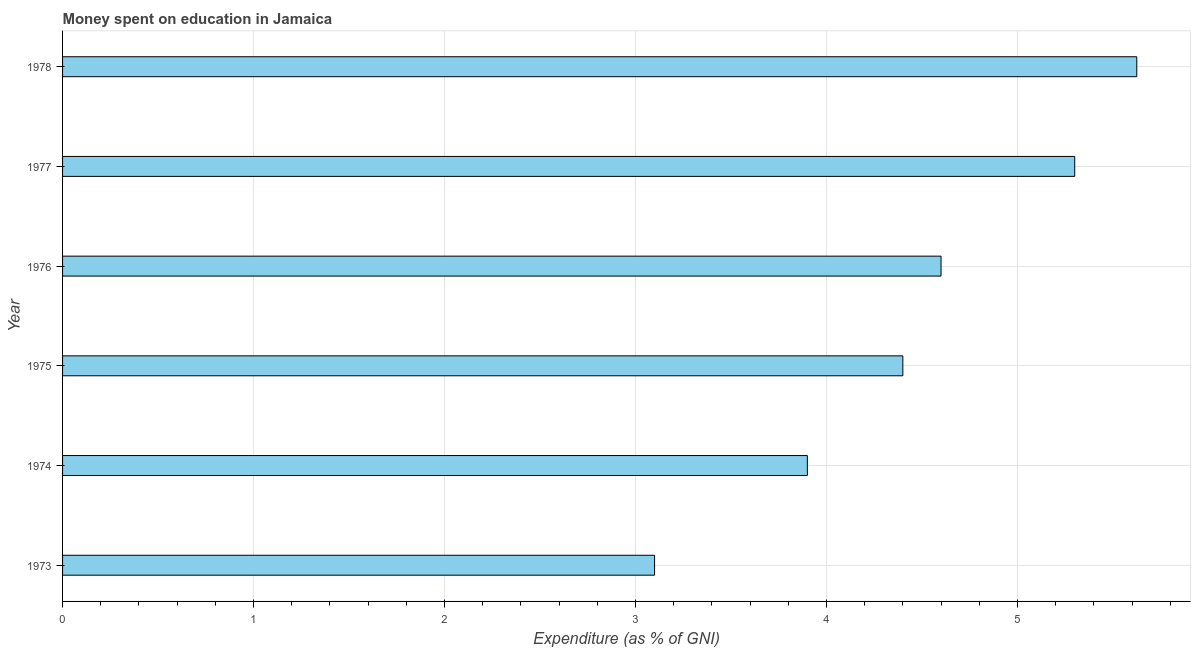Does the graph contain any zero values?
Offer a terse response. No. Does the graph contain grids?
Offer a terse response. Yes. What is the title of the graph?
Your answer should be compact. Money spent on education in Jamaica. What is the label or title of the X-axis?
Your answer should be very brief. Expenditure (as % of GNI). What is the label or title of the Y-axis?
Give a very brief answer. Year. What is the expenditure on education in 1978?
Your response must be concise. 5.63. Across all years, what is the maximum expenditure on education?
Ensure brevity in your answer.  5.63. Across all years, what is the minimum expenditure on education?
Provide a short and direct response. 3.1. In which year was the expenditure on education maximum?
Provide a succinct answer. 1978. What is the sum of the expenditure on education?
Your response must be concise. 26.93. What is the difference between the expenditure on education in 1975 and 1977?
Your response must be concise. -0.9. What is the average expenditure on education per year?
Ensure brevity in your answer.  4.49. In how many years, is the expenditure on education greater than 2.4 %?
Give a very brief answer. 6. What is the ratio of the expenditure on education in 1975 to that in 1976?
Give a very brief answer. 0.96. Is the expenditure on education in 1975 less than that in 1977?
Give a very brief answer. Yes. What is the difference between the highest and the second highest expenditure on education?
Ensure brevity in your answer.  0.33. What is the difference between the highest and the lowest expenditure on education?
Your response must be concise. 2.53. How many bars are there?
Keep it short and to the point. 6. How many years are there in the graph?
Offer a terse response. 6. What is the difference between two consecutive major ticks on the X-axis?
Your response must be concise. 1. What is the Expenditure (as % of GNI) of 1973?
Your answer should be compact. 3.1. What is the Expenditure (as % of GNI) in 1974?
Give a very brief answer. 3.9. What is the Expenditure (as % of GNI) in 1976?
Offer a terse response. 4.6. What is the Expenditure (as % of GNI) of 1978?
Provide a short and direct response. 5.63. What is the difference between the Expenditure (as % of GNI) in 1973 and 1975?
Your response must be concise. -1.3. What is the difference between the Expenditure (as % of GNI) in 1973 and 1977?
Provide a short and direct response. -2.2. What is the difference between the Expenditure (as % of GNI) in 1973 and 1978?
Offer a very short reply. -2.52. What is the difference between the Expenditure (as % of GNI) in 1974 and 1976?
Provide a short and direct response. -0.7. What is the difference between the Expenditure (as % of GNI) in 1974 and 1978?
Provide a succinct answer. -1.73. What is the difference between the Expenditure (as % of GNI) in 1975 and 1976?
Your answer should be very brief. -0.2. What is the difference between the Expenditure (as % of GNI) in 1975 and 1978?
Provide a short and direct response. -1.23. What is the difference between the Expenditure (as % of GNI) in 1976 and 1977?
Your response must be concise. -0.7. What is the difference between the Expenditure (as % of GNI) in 1976 and 1978?
Make the answer very short. -1.02. What is the difference between the Expenditure (as % of GNI) in 1977 and 1978?
Make the answer very short. -0.33. What is the ratio of the Expenditure (as % of GNI) in 1973 to that in 1974?
Offer a very short reply. 0.8. What is the ratio of the Expenditure (as % of GNI) in 1973 to that in 1975?
Make the answer very short. 0.7. What is the ratio of the Expenditure (as % of GNI) in 1973 to that in 1976?
Provide a short and direct response. 0.67. What is the ratio of the Expenditure (as % of GNI) in 1973 to that in 1977?
Give a very brief answer. 0.58. What is the ratio of the Expenditure (as % of GNI) in 1973 to that in 1978?
Offer a terse response. 0.55. What is the ratio of the Expenditure (as % of GNI) in 1974 to that in 1975?
Ensure brevity in your answer.  0.89. What is the ratio of the Expenditure (as % of GNI) in 1974 to that in 1976?
Your answer should be compact. 0.85. What is the ratio of the Expenditure (as % of GNI) in 1974 to that in 1977?
Offer a terse response. 0.74. What is the ratio of the Expenditure (as % of GNI) in 1974 to that in 1978?
Your answer should be very brief. 0.69. What is the ratio of the Expenditure (as % of GNI) in 1975 to that in 1976?
Offer a terse response. 0.96. What is the ratio of the Expenditure (as % of GNI) in 1975 to that in 1977?
Offer a very short reply. 0.83. What is the ratio of the Expenditure (as % of GNI) in 1975 to that in 1978?
Provide a short and direct response. 0.78. What is the ratio of the Expenditure (as % of GNI) in 1976 to that in 1977?
Offer a very short reply. 0.87. What is the ratio of the Expenditure (as % of GNI) in 1976 to that in 1978?
Offer a terse response. 0.82. What is the ratio of the Expenditure (as % of GNI) in 1977 to that in 1978?
Provide a short and direct response. 0.94. 